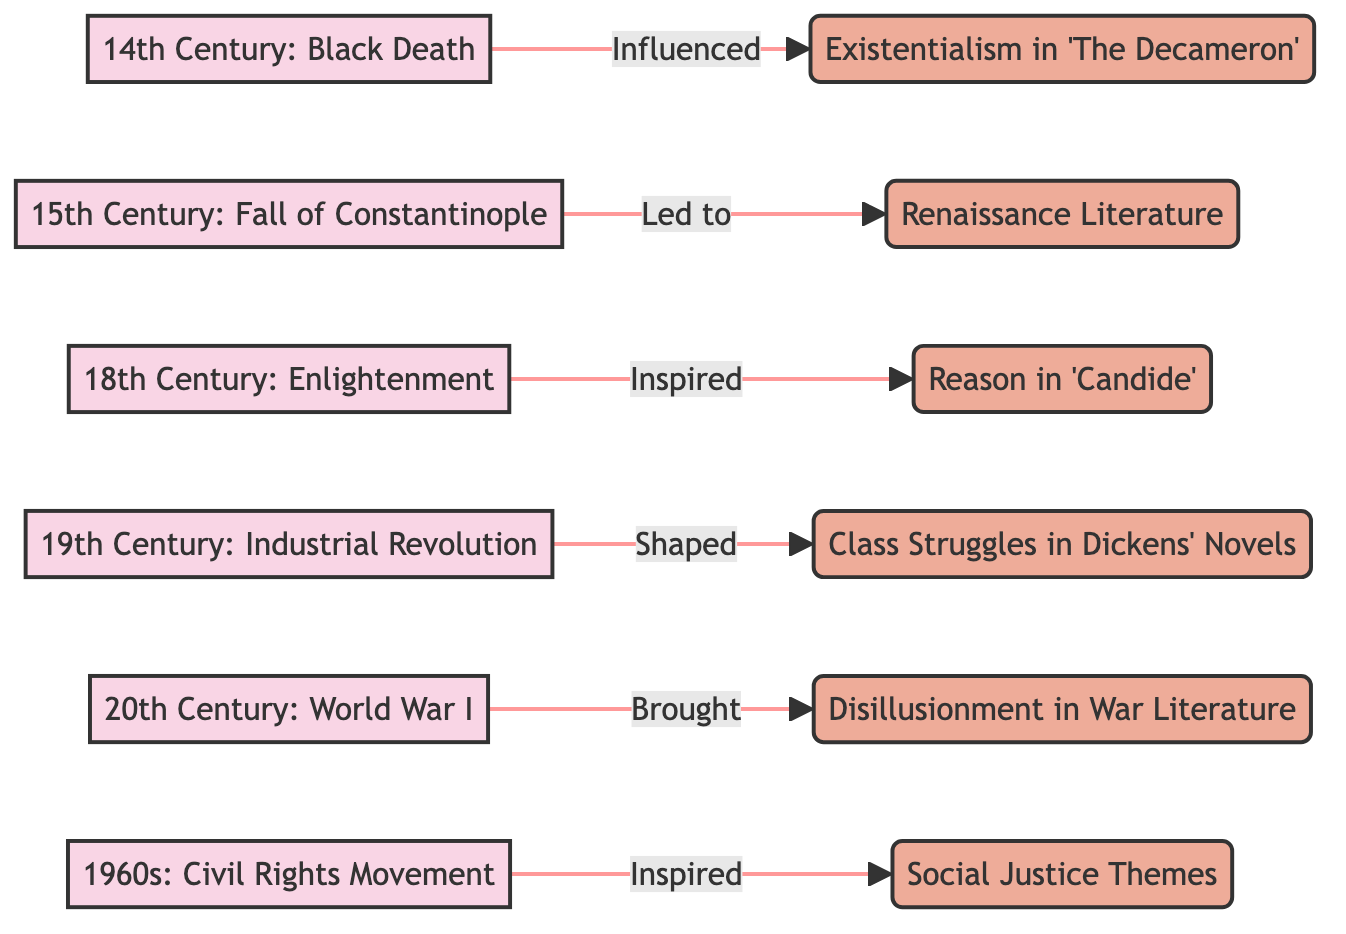What event influenced existentialism in 'The Decameron'? The diagram shows an arrow leading from the '14th Century: Black Death' node to the 'Existentialism in 'The Decameron'' node, indicating a direct influence. Therefore, the event that influenced this theme is clearly noted.
Answer: Black Death Which century is connected to the Civil Rights Movement? Looking at the flowchart, the 'Civil Rights Movement' is found at the '1960s' node, indicating that it is connected to that decade.
Answer: 1960s How many major events are represented in the diagram? The diagram lists six distinct events with associated influences, each represented by a node. Counting these gives us a total of six major events.
Answer: 6 What literary theme was shaped by the Industrial Revolution? The '19th Century: Industrial Revolution' node has an arrow pointing to 'Class Struggles in Dickens' Novels,' showing that the theme shaped by this event is class struggles.
Answer: Class Struggles in Dickens' Novels What influenced literature in the 18th century? The diagram shows the '18th Century: Enlightenment' node leading to 'Reason in 'Candide',' suggesting that the Enlightenment was an influence on literature during this century.
Answer: Reason in 'Candide' Which influence follows the event of World War I? The flowchart displays '20th Century: World War I' leading to 'Disillusionment in War Literature', indicating that disillusionment is the influence following this event in a direct relationship.
Answer: Disillusionment in War Literature What event is associated with Renaissance literature? The '15th Century: Fall of Constantinople' node connects to 'Renaissance Literature', showing that this event is directly associated with that literary movement.
Answer: Fall of Constantinople Which two movements are connected through the representation of social justice themes? In the diagram, the 'Civil Rights Movement' from the 1960s connects to 'Social Justice Themes', indicating that these two elements share a direct connection through the influence represented.
Answer: Civil Rights Movement, Social Justice Themes 